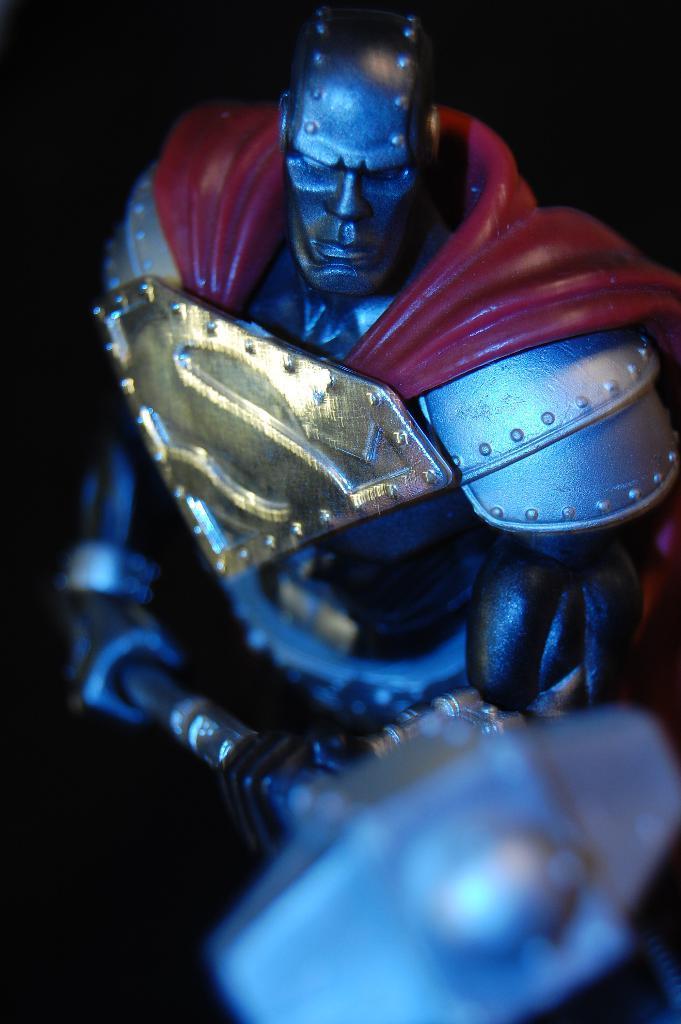Could you give a brief overview of what you see in this image? There is a toy holding a hammer is present as we can see in the middle of this image. 